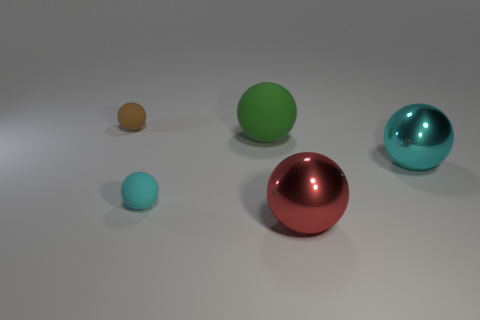Subtract all brown balls. How many balls are left? 4 Subtract all cyan matte balls. How many balls are left? 4 Subtract all yellow balls. Subtract all yellow cylinders. How many balls are left? 5 Add 2 tiny red objects. How many objects exist? 7 Add 3 small matte cylinders. How many small matte cylinders exist? 3 Subtract 0 gray cubes. How many objects are left? 5 Subtract all tiny balls. Subtract all tiny rubber objects. How many objects are left? 1 Add 4 large red spheres. How many large red spheres are left? 5 